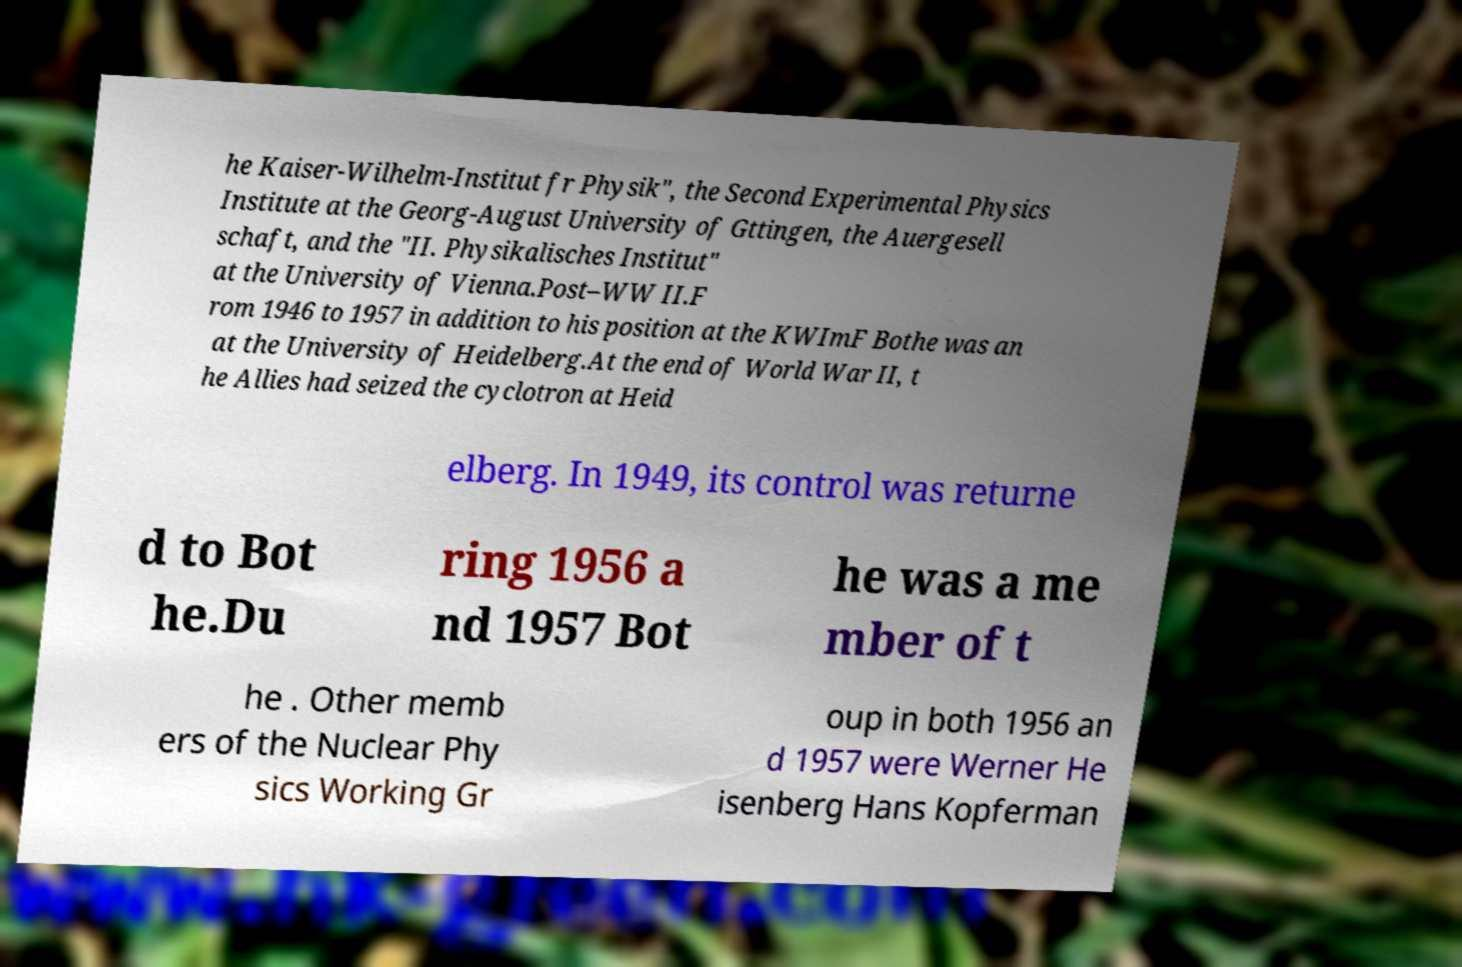Could you extract and type out the text from this image? he Kaiser-Wilhelm-Institut fr Physik", the Second Experimental Physics Institute at the Georg-August University of Gttingen, the Auergesell schaft, and the "II. Physikalisches Institut" at the University of Vienna.Post–WW II.F rom 1946 to 1957 in addition to his position at the KWImF Bothe was an at the University of Heidelberg.At the end of World War II, t he Allies had seized the cyclotron at Heid elberg. In 1949, its control was returne d to Bot he.Du ring 1956 a nd 1957 Bot he was a me mber of t he . Other memb ers of the Nuclear Phy sics Working Gr oup in both 1956 an d 1957 were Werner He isenberg Hans Kopferman 